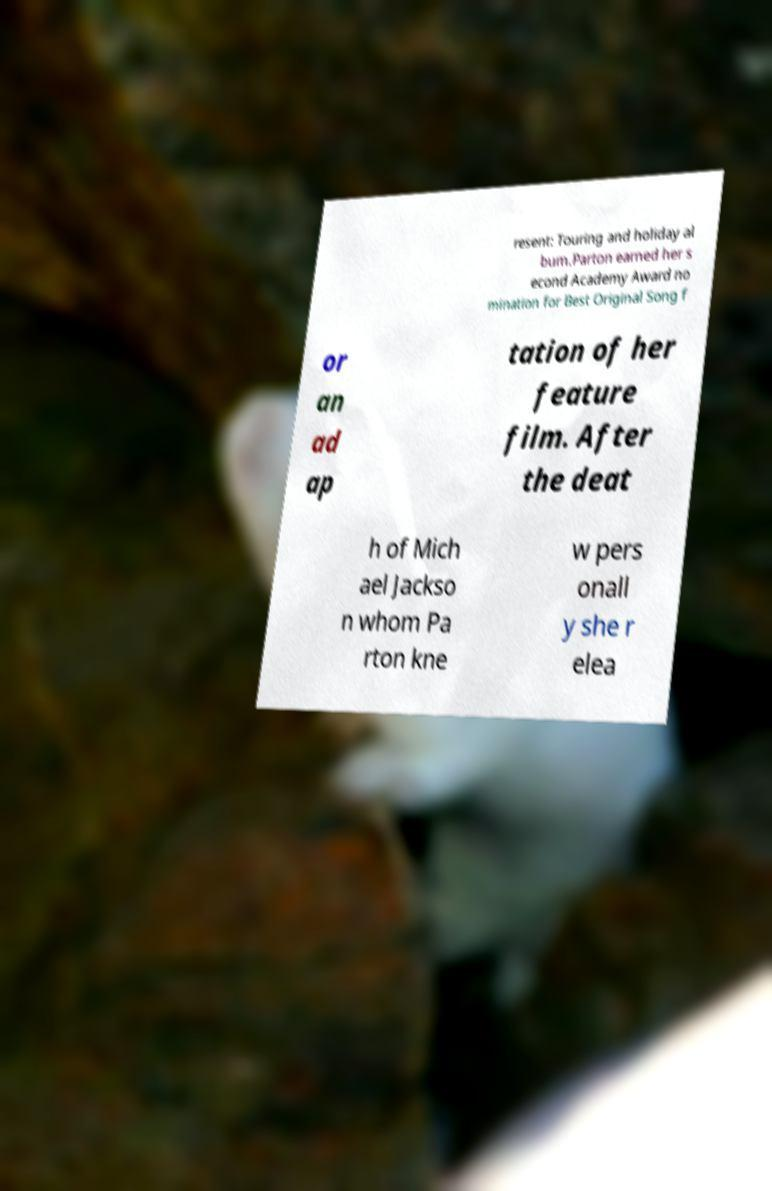Can you read and provide the text displayed in the image?This photo seems to have some interesting text. Can you extract and type it out for me? resent: Touring and holiday al bum.Parton earned her s econd Academy Award no mination for Best Original Song f or an ad ap tation of her feature film. After the deat h of Mich ael Jackso n whom Pa rton kne w pers onall y she r elea 